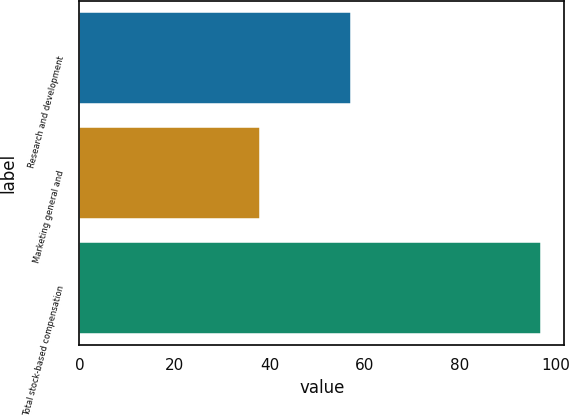Convert chart. <chart><loc_0><loc_0><loc_500><loc_500><bar_chart><fcel>Research and development<fcel>Marketing general and<fcel>Total stock-based compensation<nl><fcel>57<fcel>38<fcel>97<nl></chart> 